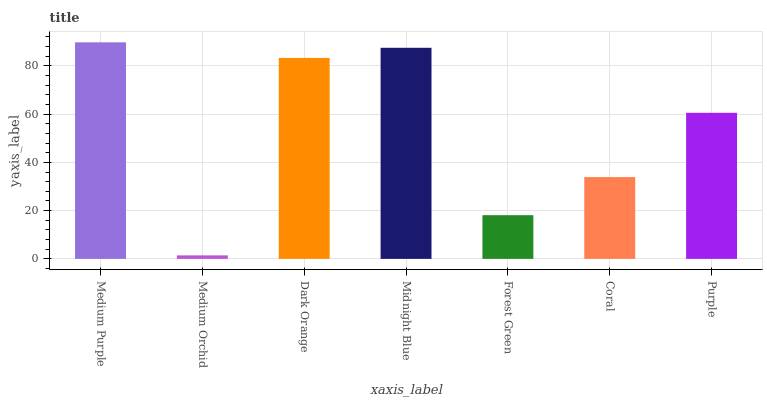Is Medium Orchid the minimum?
Answer yes or no. Yes. Is Medium Purple the maximum?
Answer yes or no. Yes. Is Dark Orange the minimum?
Answer yes or no. No. Is Dark Orange the maximum?
Answer yes or no. No. Is Dark Orange greater than Medium Orchid?
Answer yes or no. Yes. Is Medium Orchid less than Dark Orange?
Answer yes or no. Yes. Is Medium Orchid greater than Dark Orange?
Answer yes or no. No. Is Dark Orange less than Medium Orchid?
Answer yes or no. No. Is Purple the high median?
Answer yes or no. Yes. Is Purple the low median?
Answer yes or no. Yes. Is Dark Orange the high median?
Answer yes or no. No. Is Dark Orange the low median?
Answer yes or no. No. 